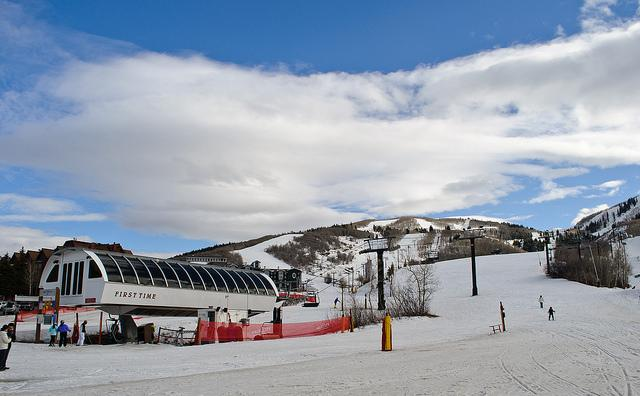Which skiers gather under the pavilion nearest here?

Choices:
A) beginners
B) retirees
C) olympians
D) pros beginners 